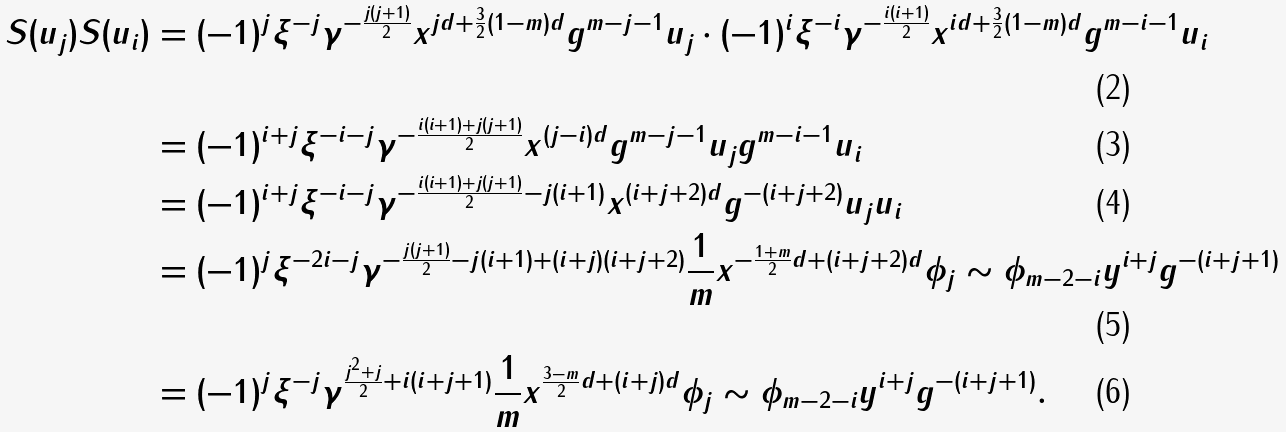<formula> <loc_0><loc_0><loc_500><loc_500>S ( u _ { j } ) S ( u _ { i } ) & = ( - 1 ) ^ { j } \xi ^ { - j } \gamma ^ { - \frac { j ( j + 1 ) } { 2 } } x ^ { j d + \frac { 3 } { 2 } ( 1 - m ) d } g ^ { m - j - 1 } u _ { j } \cdot ( - 1 ) ^ { i } \xi ^ { - i } \gamma ^ { - \frac { i ( i + 1 ) } { 2 } } x ^ { i d + \frac { 3 } { 2 } ( 1 - m ) d } g ^ { m - i - 1 } u _ { i } \\ & = ( - 1 ) ^ { i + j } \xi ^ { - i - j } \gamma ^ { - \frac { i ( i + 1 ) + j ( j + 1 ) } { 2 } } x ^ { ( j - i ) d } g ^ { m - j - 1 } u _ { j } g ^ { m - i - 1 } u _ { i } \\ & = ( - 1 ) ^ { i + j } \xi ^ { - i - j } \gamma ^ { - \frac { i ( i + 1 ) + j ( j + 1 ) } { 2 } - j ( i + 1 ) } x ^ { ( i + j + 2 ) d } g ^ { - ( i + j + 2 ) } u _ { j } u _ { i } \\ & = ( - 1 ) ^ { j } \xi ^ { - 2 i - j } \gamma ^ { - \frac { j ( j + 1 ) } { 2 } - j ( i + 1 ) + ( i + j ) ( i + j + 2 ) } \frac { 1 } { m } x ^ { - \frac { 1 + m } { 2 } d + ( i + j + 2 ) d } \phi _ { j } \sim \phi _ { m - 2 - i } y ^ { i + j } g ^ { - ( i + j + 1 ) } \\ & = ( - 1 ) ^ { j } \xi ^ { - j } \gamma ^ { \frac { j ^ { 2 } + j } { 2 } + i ( i + j + 1 ) } \frac { 1 } { m } x ^ { \frac { 3 - m } { 2 } d + ( i + j ) d } \phi _ { j } \sim \phi _ { m - 2 - i } y ^ { i + j } g ^ { - ( i + j + 1 ) } .</formula> 